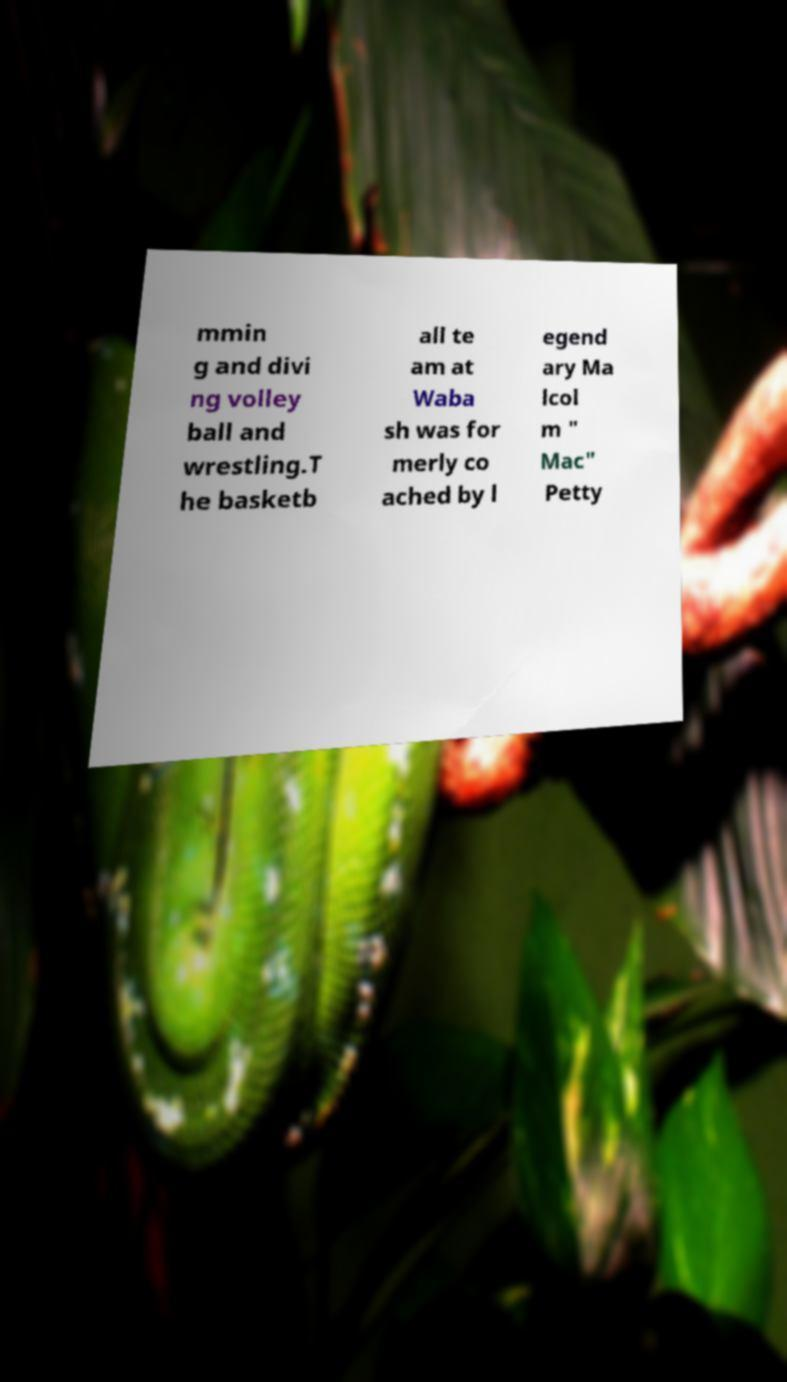I need the written content from this picture converted into text. Can you do that? mmin g and divi ng volley ball and wrestling.T he basketb all te am at Waba sh was for merly co ached by l egend ary Ma lcol m " Mac" Petty 